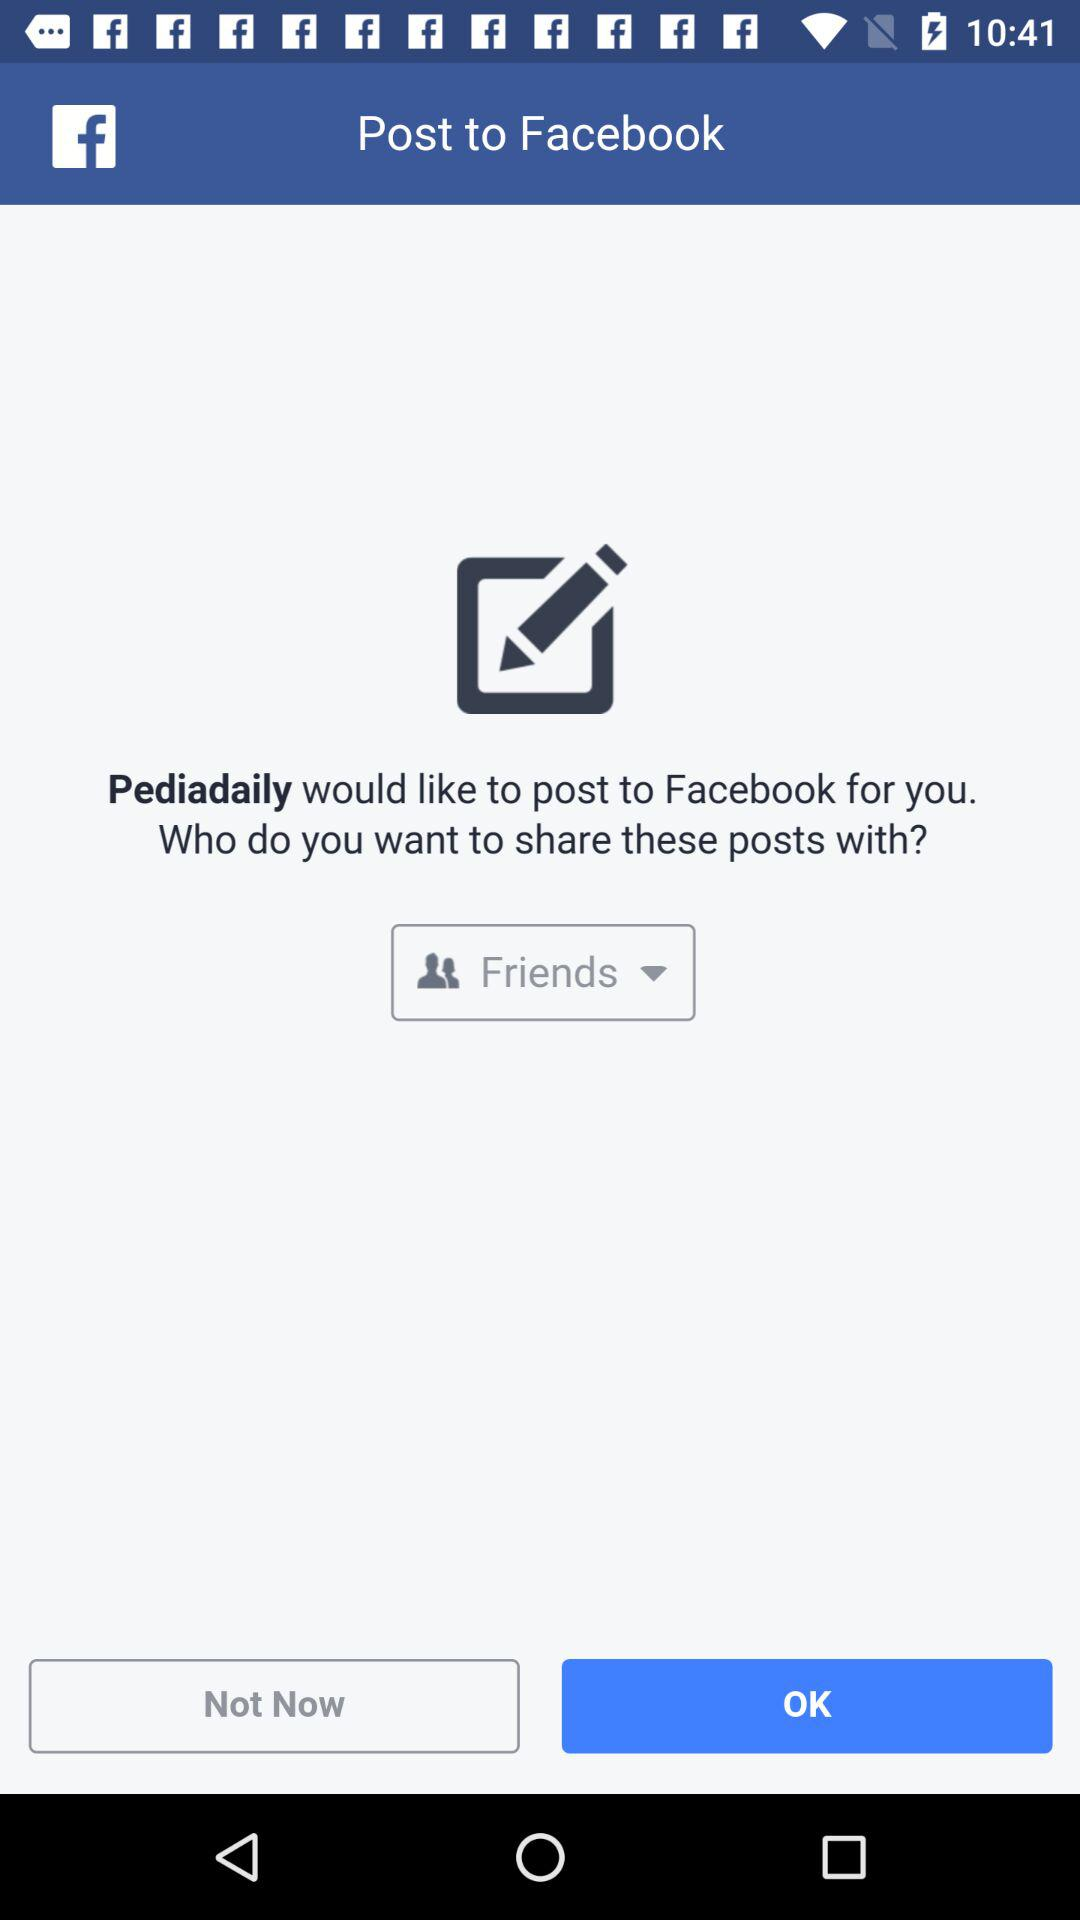What application would like to post to Facebook for you? The application that would like to post to Facebook is "Pediadaily". 